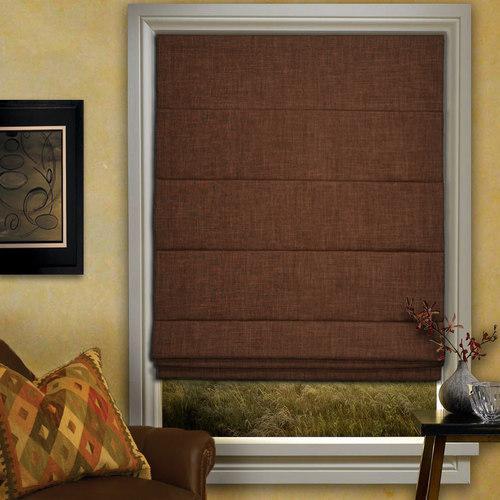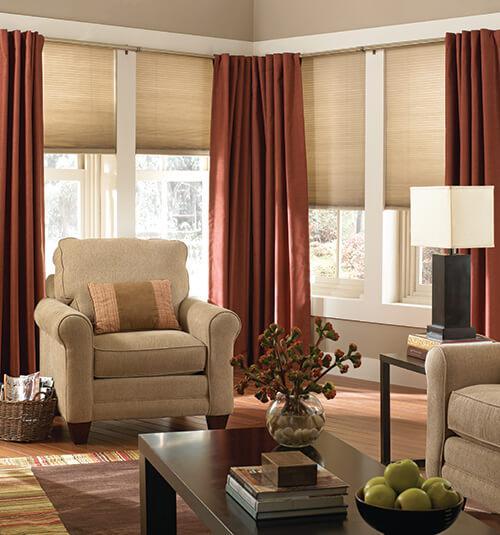The first image is the image on the left, the second image is the image on the right. Given the left and right images, does the statement "There are exactly two window shades in the right image." hold true? Answer yes or no. No. The first image is the image on the left, the second image is the image on the right. Evaluate the accuracy of this statement regarding the images: "There is a total of three blinds.". Is it true? Answer yes or no. No. 